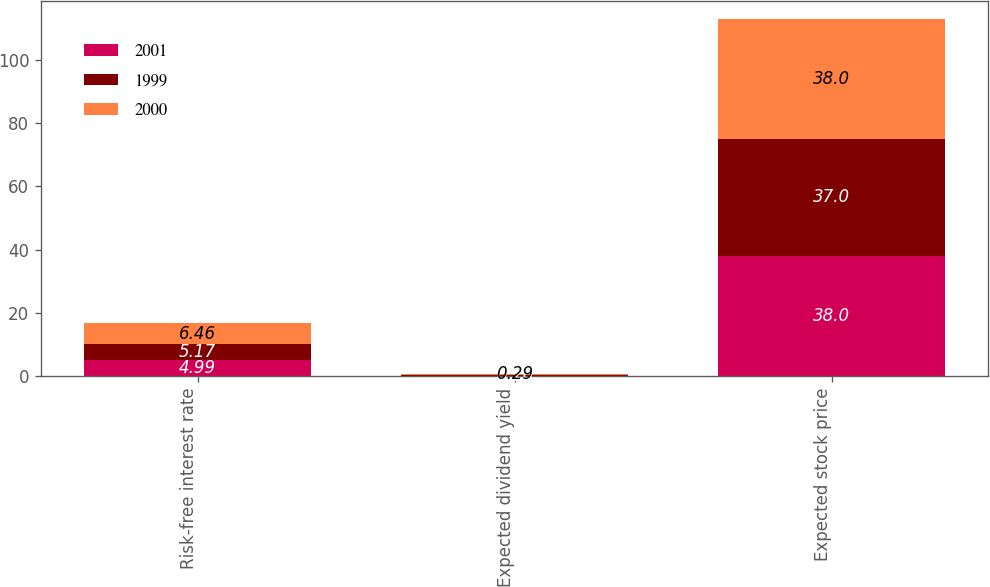Convert chart to OTSL. <chart><loc_0><loc_0><loc_500><loc_500><stacked_bar_chart><ecel><fcel>Risk-free interest rate<fcel>Expected dividend yield<fcel>Expected stock price<nl><fcel>2001<fcel>4.99<fcel>0.15<fcel>38<nl><fcel>1999<fcel>5.17<fcel>0.26<fcel>37<nl><fcel>2000<fcel>6.46<fcel>0.29<fcel>38<nl></chart> 